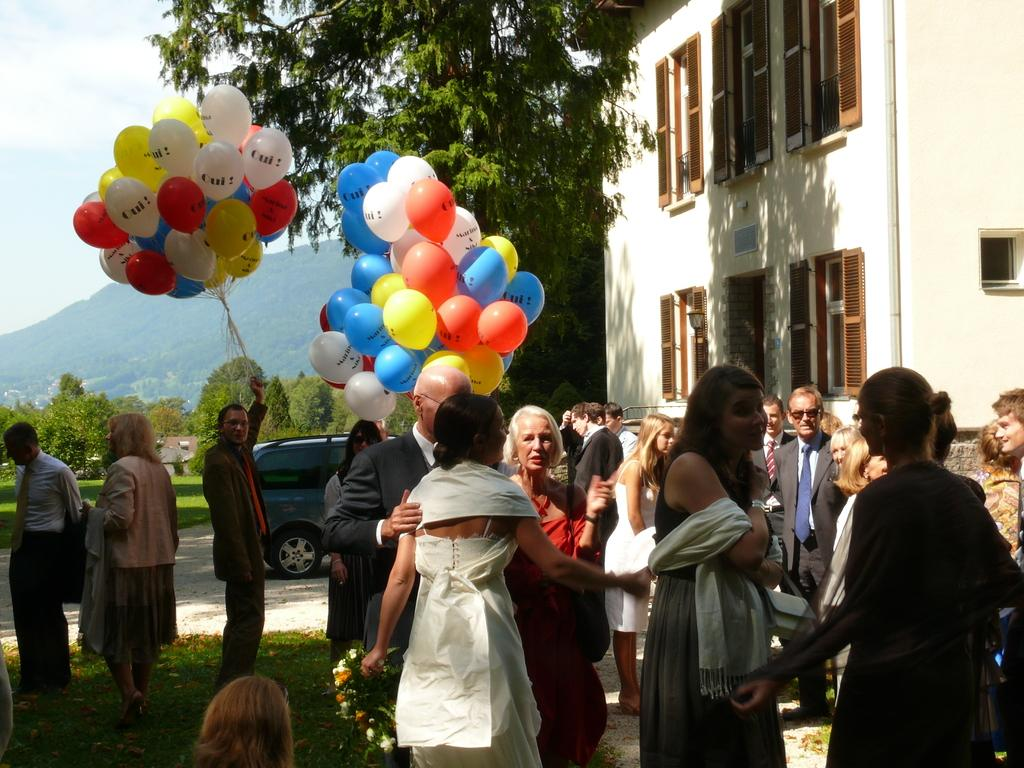How many people are in the image? There are people in the image, but the exact number is not specified. What are some people holding in the image? Some people are holding balloons in the image. What can be seen in the background of the image? In the background of the image, there is a car, trees, a mountain, and the sky. Where is the building located in the image? The building is in the top right corner of the image. How many tickets does the playground have in the image? There is no playground or tickets present in the image. What color is the eye of the person in the image? There is no mention of a person's eye in the image, so we cannot determine its color. 